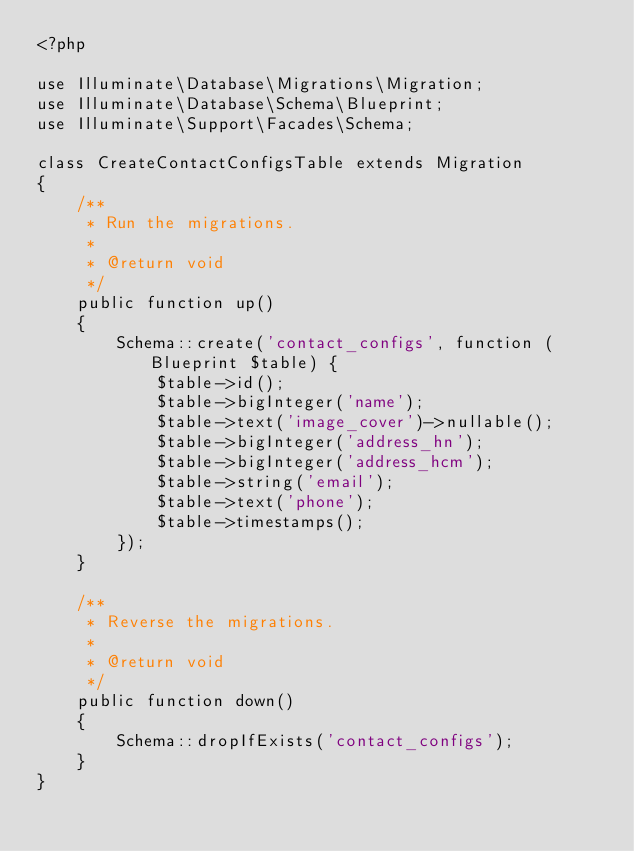<code> <loc_0><loc_0><loc_500><loc_500><_PHP_><?php

use Illuminate\Database\Migrations\Migration;
use Illuminate\Database\Schema\Blueprint;
use Illuminate\Support\Facades\Schema;

class CreateContactConfigsTable extends Migration
{
    /**
     * Run the migrations.
     *
     * @return void
     */
    public function up()
    {
        Schema::create('contact_configs', function (Blueprint $table) {
            $table->id();
            $table->bigInteger('name');
            $table->text('image_cover')->nullable();
            $table->bigInteger('address_hn');
            $table->bigInteger('address_hcm');
            $table->string('email');
            $table->text('phone');
            $table->timestamps();
        });
    }

    /**
     * Reverse the migrations.
     *
     * @return void
     */
    public function down()
    {
        Schema::dropIfExists('contact_configs');
    }
}
</code> 